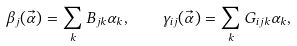Convert formula to latex. <formula><loc_0><loc_0><loc_500><loc_500>\beta _ { j } ( \vec { \alpha } ) = \sum _ { k } B _ { j k } \alpha _ { k } , \quad \gamma _ { i j } ( \vec { \alpha } ) = \sum _ { k } G _ { i j k } \alpha _ { k } ,</formula> 